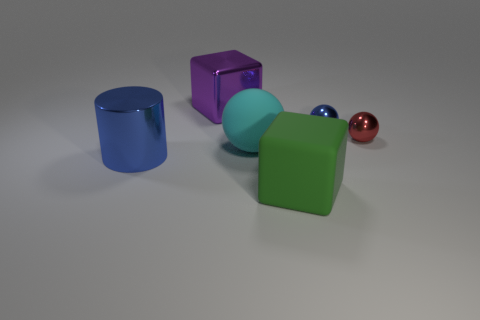Add 1 small blue metal spheres. How many objects exist? 7 Subtract all red balls. How many balls are left? 2 Subtract all red balls. How many balls are left? 2 Subtract all yellow matte blocks. Subtract all purple shiny things. How many objects are left? 5 Add 4 green rubber cubes. How many green rubber cubes are left? 5 Add 4 purple shiny objects. How many purple shiny objects exist? 5 Subtract 0 green cylinders. How many objects are left? 6 Subtract all blocks. How many objects are left? 4 Subtract 1 cylinders. How many cylinders are left? 0 Subtract all brown cylinders. Subtract all brown blocks. How many cylinders are left? 1 